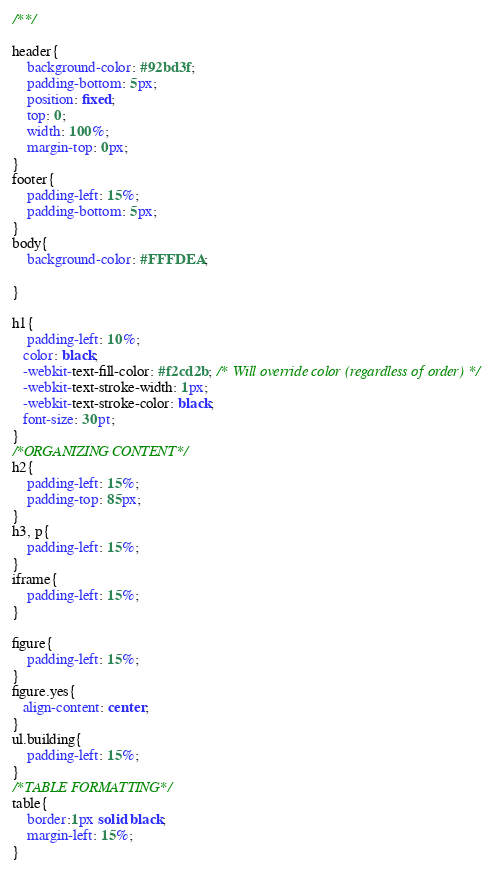<code> <loc_0><loc_0><loc_500><loc_500><_CSS_>/**/

header{
    background-color: #92bd3f;
    padding-bottom: 5px;
    position: fixed;
    top: 0;
    width: 100%;
    margin-top: 0px;
}
footer{
    padding-left: 15%;
    padding-bottom: 5px;
}
body{
    background-color: #FFFDEA;
        
}

h1{
    padding-left: 10%;
   color: black;
   -webkit-text-fill-color: #f2cd2b; /* Will override color (regardless of order) */
   -webkit-text-stroke-width: 1px;
   -webkit-text-stroke-color: black;
   font-size: 30pt;
}
/*ORGANIZING CONTENT*/
h2{
    padding-left: 15%;
    padding-top: 85px;
}
h3, p{
    padding-left: 15%;
}
iframe{
    padding-left: 15%;
}

figure{
    padding-left: 15%;
}
figure.yes{
   align-content: center;
}
ul.building{
    padding-left: 15%;
}
/*TABLE FORMATTING*/
table{
    border:1px solid black;
    margin-left: 15%;
}</code> 